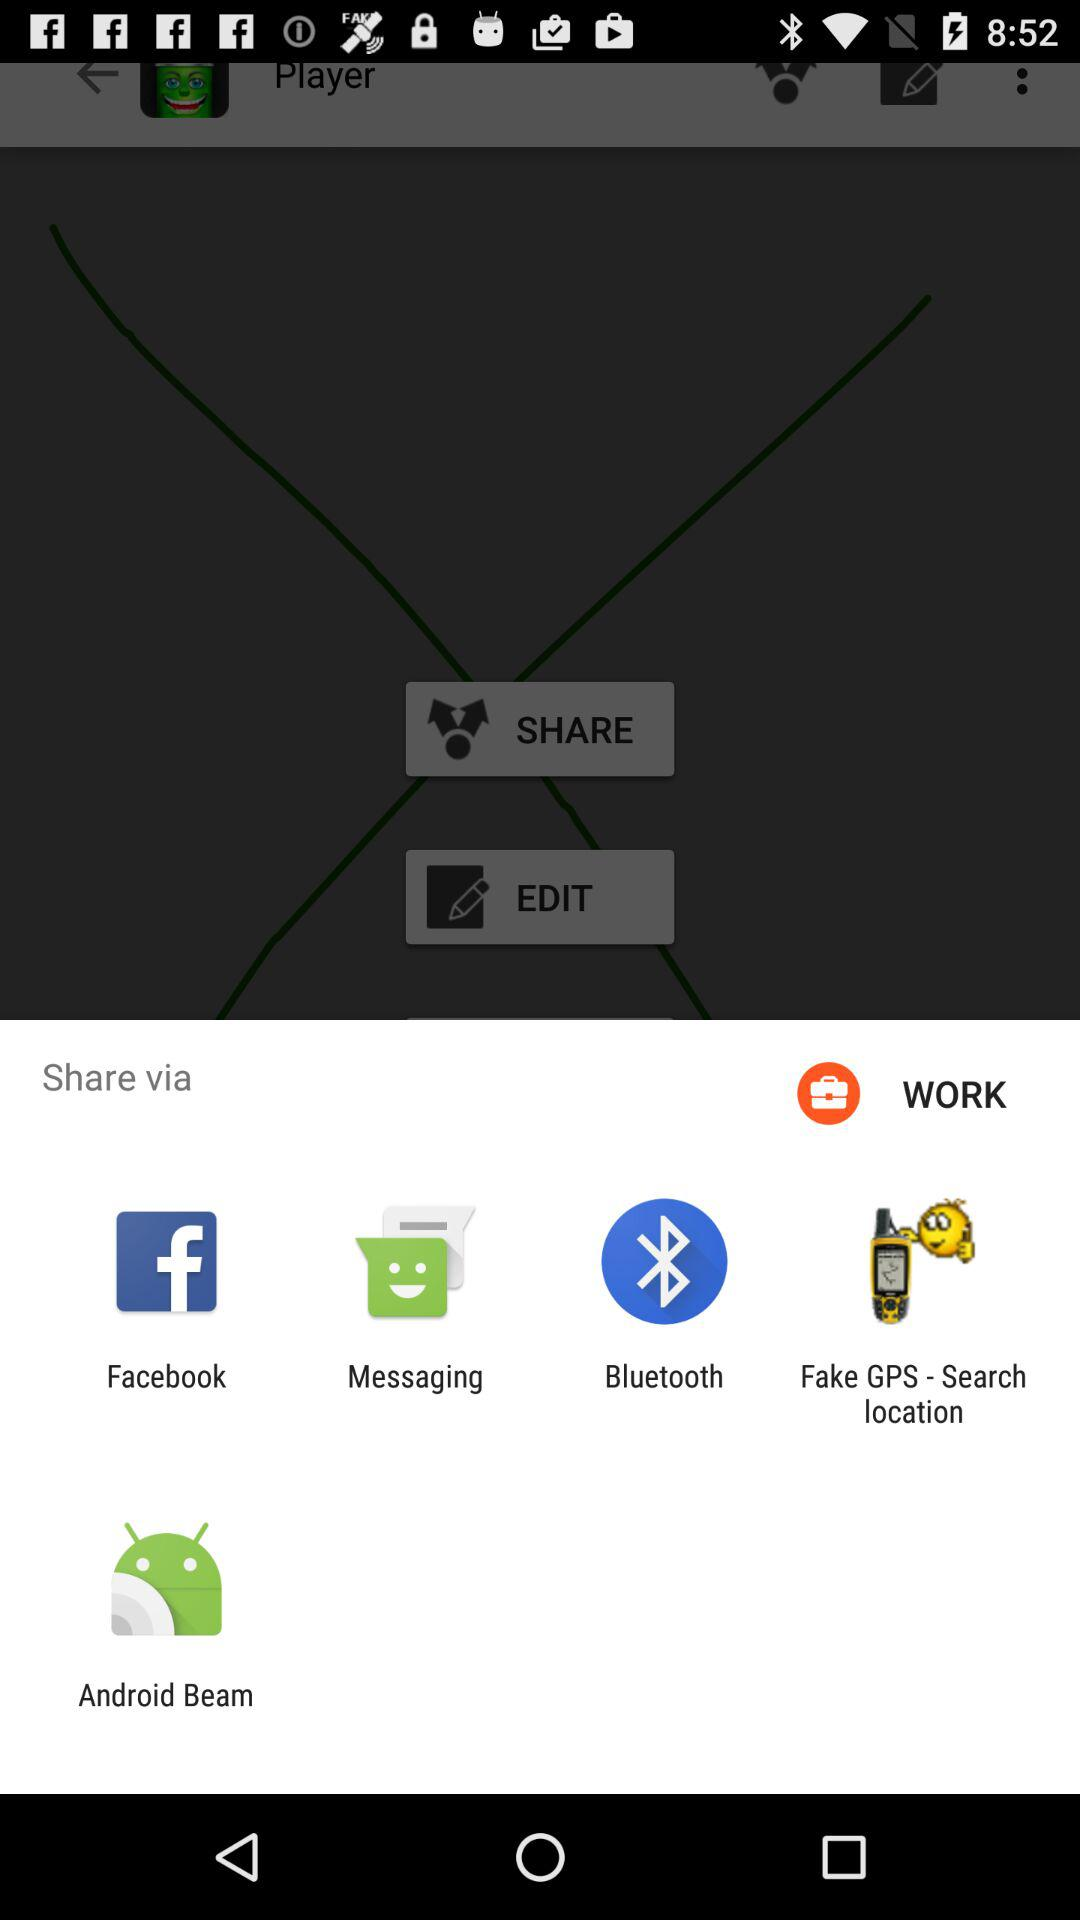Through which application can we share it? You can share the content through "Facebook", "Messaging", "Bluetooth", "Fake GPS - Search location" and "Android Beam". 